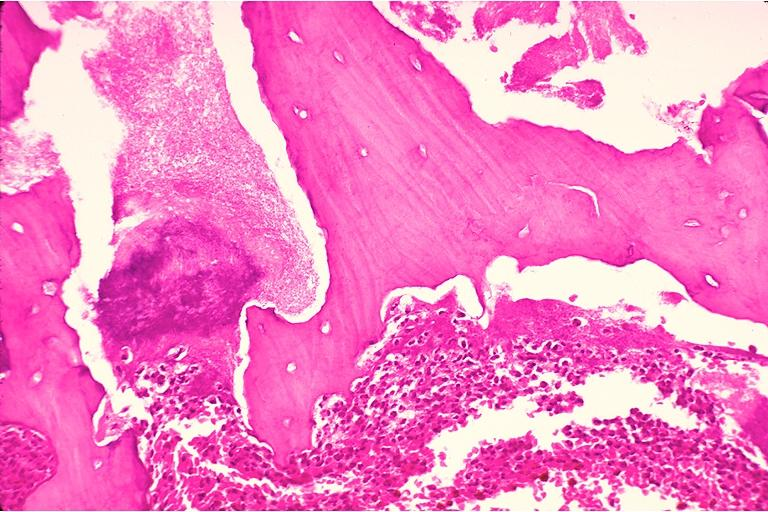s chest and abdomen slide present?
Answer the question using a single word or phrase. No 